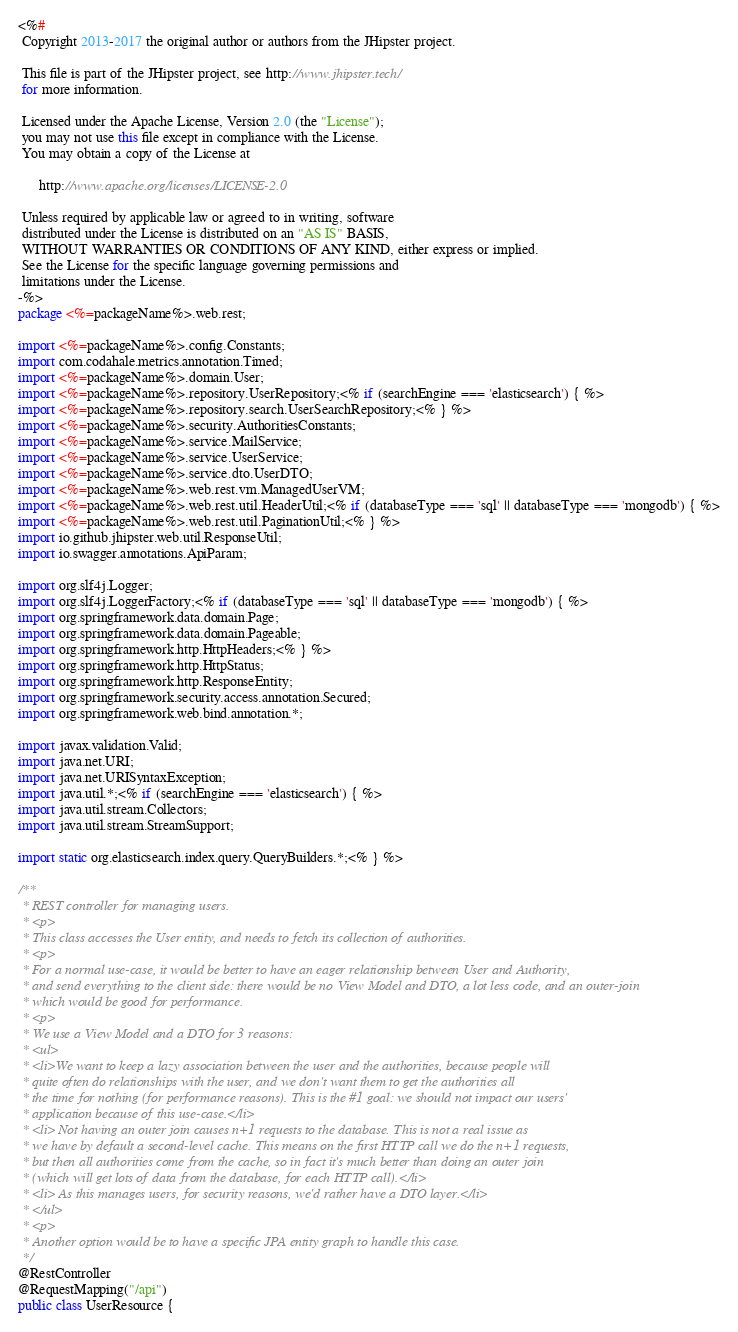Convert code to text. <code><loc_0><loc_0><loc_500><loc_500><_Java_><%#
 Copyright 2013-2017 the original author or authors from the JHipster project.

 This file is part of the JHipster project, see http://www.jhipster.tech/
 for more information.

 Licensed under the Apache License, Version 2.0 (the "License");
 you may not use this file except in compliance with the License.
 You may obtain a copy of the License at

      http://www.apache.org/licenses/LICENSE-2.0

 Unless required by applicable law or agreed to in writing, software
 distributed under the License is distributed on an "AS IS" BASIS,
 WITHOUT WARRANTIES OR CONDITIONS OF ANY KIND, either express or implied.
 See the License for the specific language governing permissions and
 limitations under the License.
-%>
package <%=packageName%>.web.rest;

import <%=packageName%>.config.Constants;
import com.codahale.metrics.annotation.Timed;
import <%=packageName%>.domain.User;
import <%=packageName%>.repository.UserRepository;<% if (searchEngine === 'elasticsearch') { %>
import <%=packageName%>.repository.search.UserSearchRepository;<% } %>
import <%=packageName%>.security.AuthoritiesConstants;
import <%=packageName%>.service.MailService;
import <%=packageName%>.service.UserService;
import <%=packageName%>.service.dto.UserDTO;
import <%=packageName%>.web.rest.vm.ManagedUserVM;
import <%=packageName%>.web.rest.util.HeaderUtil;<% if (databaseType === 'sql' || databaseType === 'mongodb') { %>
import <%=packageName%>.web.rest.util.PaginationUtil;<% } %>
import io.github.jhipster.web.util.ResponseUtil;
import io.swagger.annotations.ApiParam;

import org.slf4j.Logger;
import org.slf4j.LoggerFactory;<% if (databaseType === 'sql' || databaseType === 'mongodb') { %>
import org.springframework.data.domain.Page;
import org.springframework.data.domain.Pageable;
import org.springframework.http.HttpHeaders;<% } %>
import org.springframework.http.HttpStatus;
import org.springframework.http.ResponseEntity;
import org.springframework.security.access.annotation.Secured;
import org.springframework.web.bind.annotation.*;

import javax.validation.Valid;
import java.net.URI;
import java.net.URISyntaxException;
import java.util.*;<% if (searchEngine === 'elasticsearch') { %>
import java.util.stream.Collectors;
import java.util.stream.StreamSupport;

import static org.elasticsearch.index.query.QueryBuilders.*;<% } %>

/**
 * REST controller for managing users.
 * <p>
 * This class accesses the User entity, and needs to fetch its collection of authorities.
 * <p>
 * For a normal use-case, it would be better to have an eager relationship between User and Authority,
 * and send everything to the client side: there would be no View Model and DTO, a lot less code, and an outer-join
 * which would be good for performance.
 * <p>
 * We use a View Model and a DTO for 3 reasons:
 * <ul>
 * <li>We want to keep a lazy association between the user and the authorities, because people will
 * quite often do relationships with the user, and we don't want them to get the authorities all
 * the time for nothing (for performance reasons). This is the #1 goal: we should not impact our users'
 * application because of this use-case.</li>
 * <li> Not having an outer join causes n+1 requests to the database. This is not a real issue as
 * we have by default a second-level cache. This means on the first HTTP call we do the n+1 requests,
 * but then all authorities come from the cache, so in fact it's much better than doing an outer join
 * (which will get lots of data from the database, for each HTTP call).</li>
 * <li> As this manages users, for security reasons, we'd rather have a DTO layer.</li>
 * </ul>
 * <p>
 * Another option would be to have a specific JPA entity graph to handle this case.
 */
@RestController
@RequestMapping("/api")
public class UserResource {
</code> 